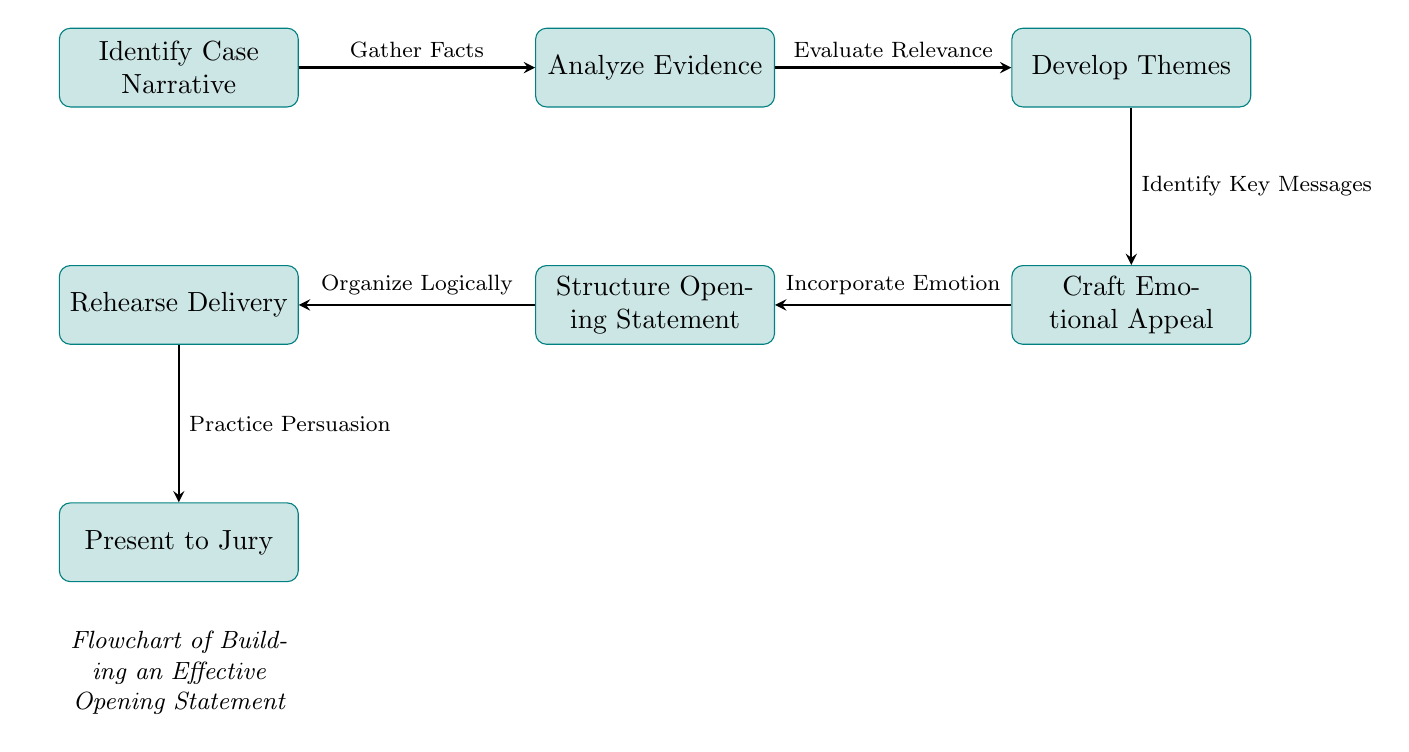What is the first stage in building an effective opening statement? The first stage in the flowchart is "Identify Case Narrative," which serves as the starting point in the process of constructing the opening statement.
Answer: Identify Case Narrative How many main stages are represented in the diagram? The diagram consists of six main stages, starting from "Identify Case Narrative" to "Present to Jury," indicating a clear process for developing the opening statement.
Answer: Six Which stage directly follows "Analyze Evidence"? The stage that directly follows "Analyze Evidence" is "Develop Themes." This represents the progression from analyzing evidence to creating overarching themes for the statement.
Answer: Develop Themes What is the relationship between "Craft Emotional Appeal" and "Structure Opening Statement"? "Craft Emotional Appeal" is positioned above "Structure Opening Statement," indicating that emotional appeal is developed before structuring the statement, emphasizing its significance in the process.
Answer: Craft Emotional Appeal is developed before Structuring What is emphasized in the transition from "Develop Themes" to "Craft Emotional Appeal"? The transition emphasizes "Identify Key Messages," indicating that it is crucial to determine the key messages from the themes in order to effectively craft an emotional appeal in the opening statement.
Answer: Identify Key Messages What is the final action to be taken according to the flowchart? The final action in the process is "Present to Jury," which is the culmination of all the stages where the opening statement is delivered to the jury.
Answer: Present to Jury What should be incorporated before structuring the opening statement? Before structuring the opening statement, "Incorporate Emotion" should be completed, highlighting the importance of emotional appeal in the narrative.
Answer: Incorporate Emotion What aspect of rehearsal is mentioned in the diagram? The aspect of rehearsal mentioned in the diagram is "Practice Persuasion," indicating that it's not just about rehearsal, but specifically about practicing persuasive delivery.
Answer: Practice Persuasion 